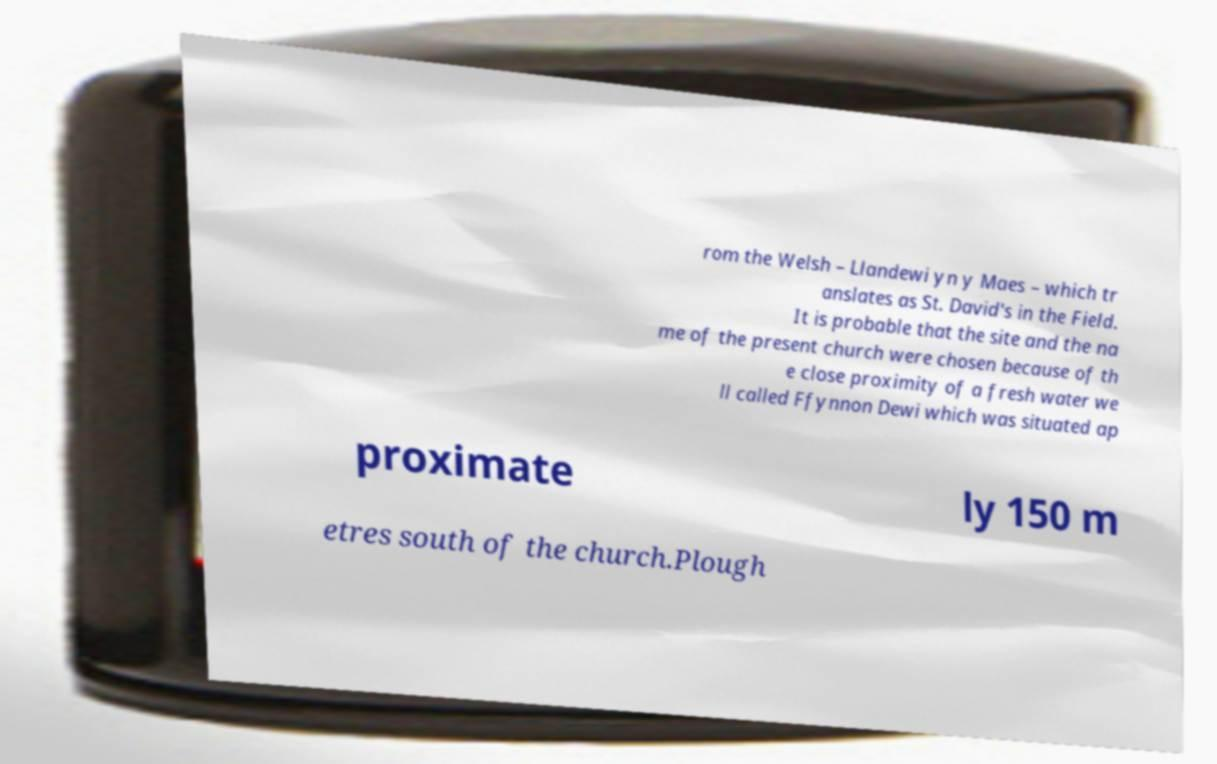Please identify and transcribe the text found in this image. rom the Welsh – Llandewi yn y Maes – which tr anslates as St. David's in the Field. It is probable that the site and the na me of the present church were chosen because of th e close proximity of a fresh water we ll called Ffynnon Dewi which was situated ap proximate ly 150 m etres south of the church.Plough 